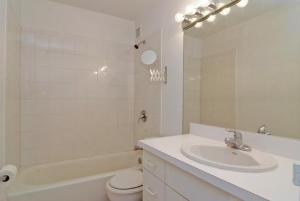Is there a separate door for the shower?
Give a very brief answer. No. Is there a mirror on the wall?
Quick response, please. Yes. Is this a modern bathroom?
Be succinct. Yes. What color is the toilet?
Be succinct. White. 